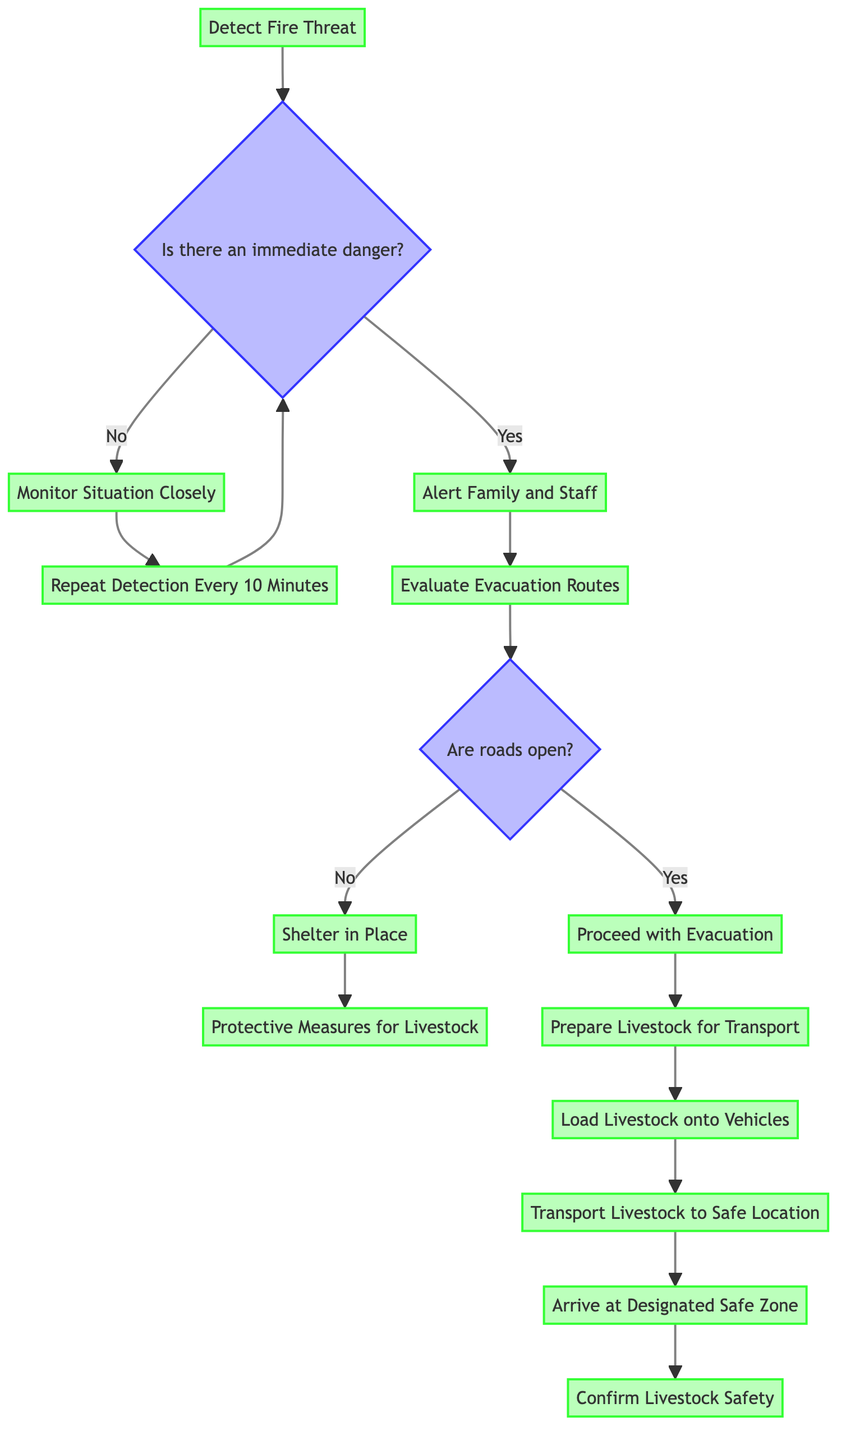What is the starting point of the flowchart? The starting point of the flowchart is "Detect Fire Threat," which is the first operation that initiates the flow of actions.
Answer: Detect Fire Threat How many operations are in the flowchart? By counting the nodes designated as operations (nodes without conditions), we find there are ten operations listed in the diagram.
Answer: Ten What happens if there is no immediate danger? If there is no immediate danger, the flowchart directs the process to "Monitor Situation Closely," which indicates that the situation will be observed rather than acted upon immediately.
Answer: Monitor Situation Closely What is the next step after "Proceed with Evacuation"? After "Proceed with Evacuation," the next step indicated in the flowchart is "Prepare Livestock for Transport," highlighting the sequential nature of the emergency plan.
Answer: Prepare Livestock for Transport What are the protective measures taken if the roads are closed? If the roads are closed, the flowchart specifies that the next step is "Shelter in Place," which involves taking actions to protect the livestock until it is safe to evacuate.
Answer: Shelter in Place What is the final operation before confirming livestock safety? The final operation before confirming livestock safety is "Arrive at Designated Safe Zone," where the livestock's safe arrival is ensured before the safety check is conducted.
Answer: Arrive at Designated Safe Zone What details are provided with "Shelter in Place"? The details for "Shelter in Place" include moving livestock to a cleared area, providing water and feed, and monitoring fire updates, which outlines the specific actions to be taken in that scenario.
Answer: Move livestock to cleared area with minimal vegetation; Provide water and feed; Monitor fire updates What condition must be met before proceeding with evacuation? The condition that must be met before proceeding with evacuation is "Are roads open?", which is a decision point determining whether evacuation is feasible.
Answer: Are roads open? Which operation needs to be repeated every ten minutes? The operation that is stated to be repeated every ten minutes is "Repeat Detection Every 10 Minutes," emphasizing ongoing monitoring during uncertain situations.
Answer: Repeat Detection Every 10 Minutes 